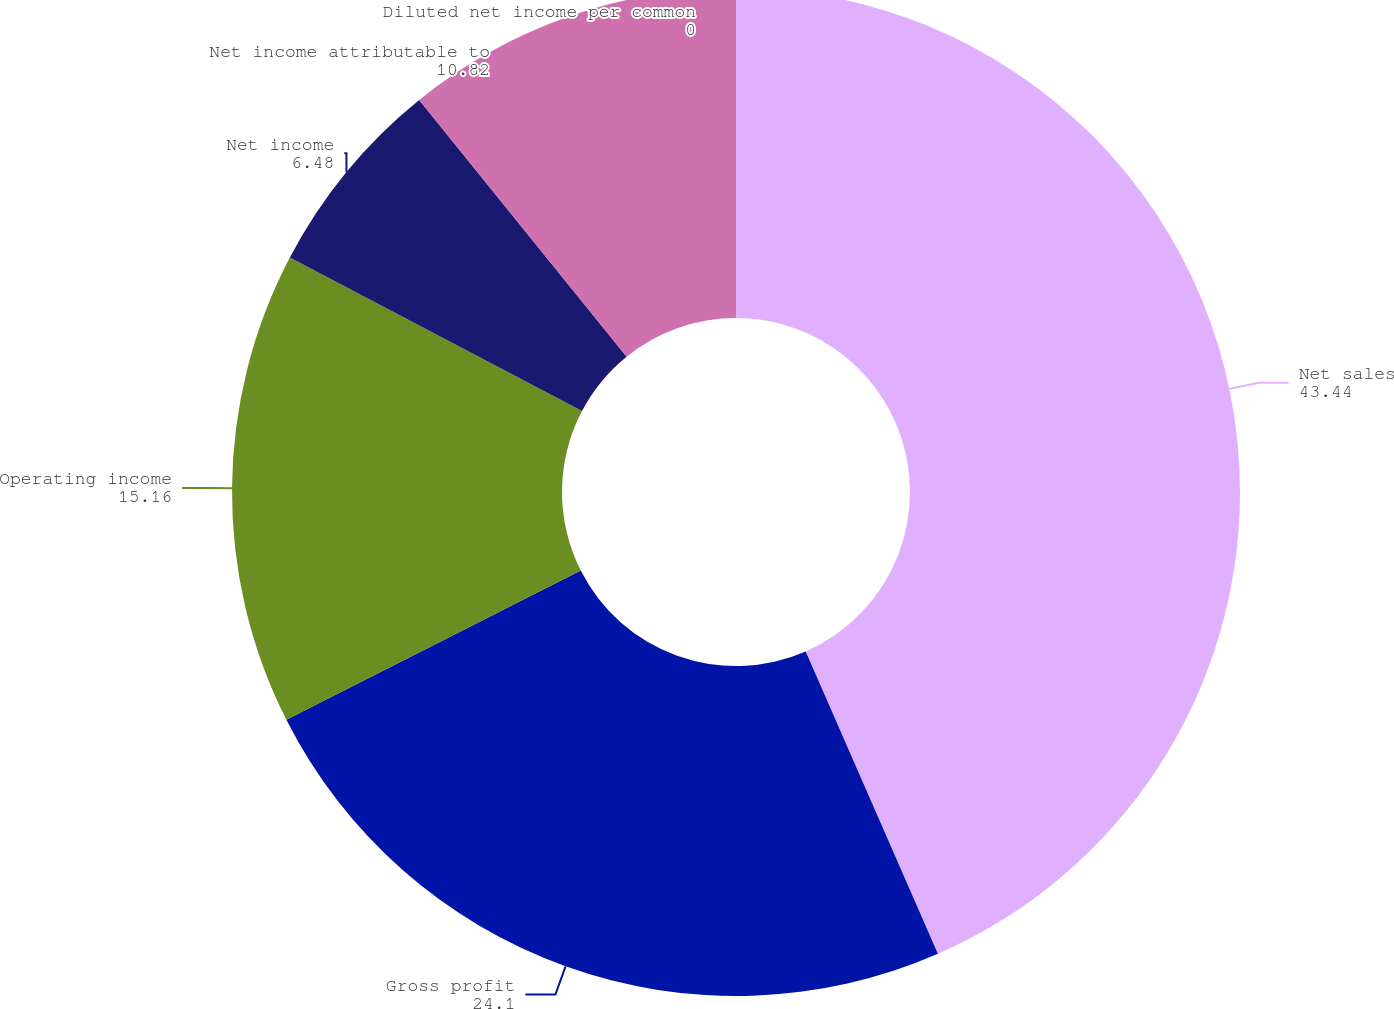<chart> <loc_0><loc_0><loc_500><loc_500><pie_chart><fcel>Net sales<fcel>Gross profit<fcel>Operating income<fcel>Net income<fcel>Net income attributable to<fcel>Diluted net income per common<nl><fcel>43.44%<fcel>24.1%<fcel>15.16%<fcel>6.48%<fcel>10.82%<fcel>0.0%<nl></chart> 